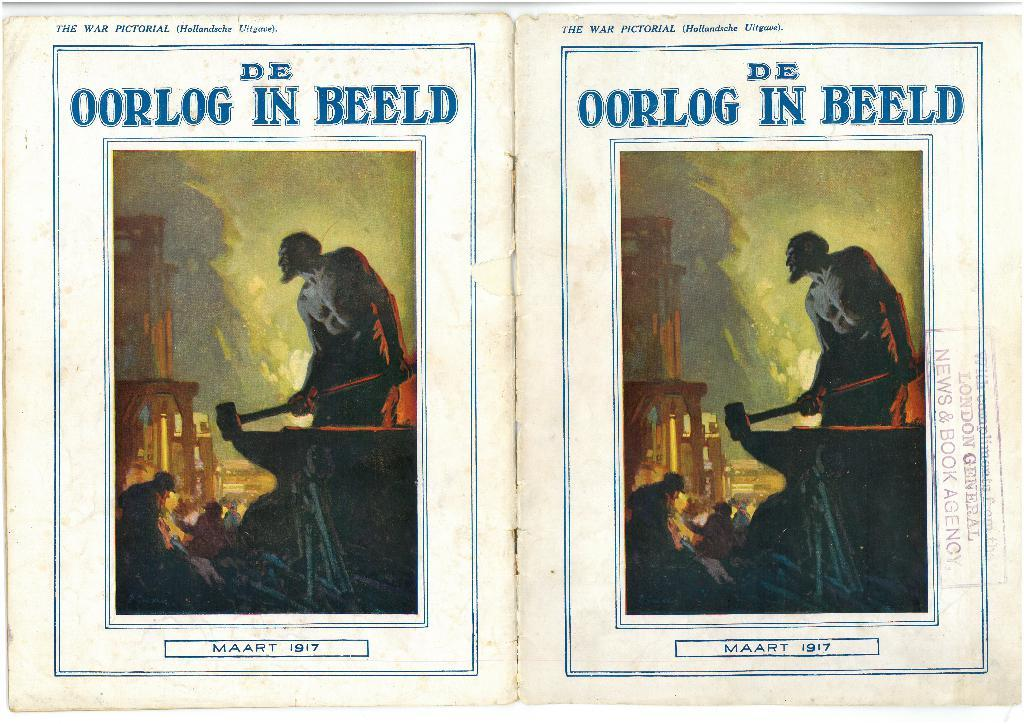<image>
Describe the image concisely. a book that has Oorlog in Beeld written on the front 